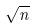Convert formula to latex. <formula><loc_0><loc_0><loc_500><loc_500>\sqrt { n }</formula> 